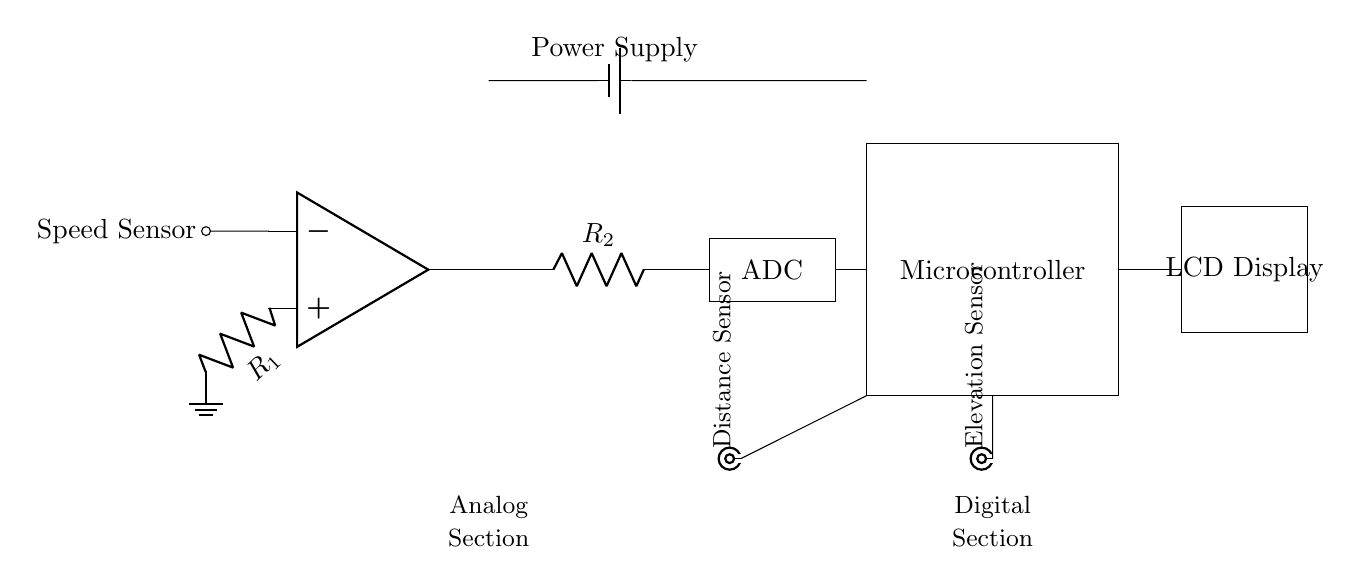What is the main power supply component in this circuit? The power supply component is a battery, identified in the circuit diagram. It is the first component connected at the top left, supplying voltage to the rest of the circuit.
Answer: Battery Which component is responsible for measuring elevation? The elevation sensor is responsible for measuring elevation data, indicated by the BNC connection labeled as "Elevation Sensor" in the diagram.
Answer: Elevation Sensor How many resistors are present in the analog section? There are two resistors labeled as R1 and R2 in the analog section connecting the operational amplifier and the ADC.
Answer: Two What type of output does the microcontroller provide to the LCD display? The microcontroller provides a digital output to the LCD display, as an intermediary processor handling the data after converting from analog to digital signals.
Answer: Digital Describe the role of the ADC in the circuit. The ADC, or Analog-to-Digital Converter, converts the analog signals generated from the speed and elevation sensors into digital values that the microcontroller can process. This is crucial for displaying accurate data on the LCD.
Answer: Converts signals Which part of the circuit is responsible for displaying data? The LCD display is responsible for displaying data such as speed, distance, and elevation to the cyclist, as shown at the right side of the diagram.
Answer: LCD Display What is the function of the operational amplifier in this circuit? The operational amplifier amplifies the signal from the speed sensor, which is important as it prepares the signal for further processing by the ADC, ensuring accurate readings.
Answer: Amplifies signal 